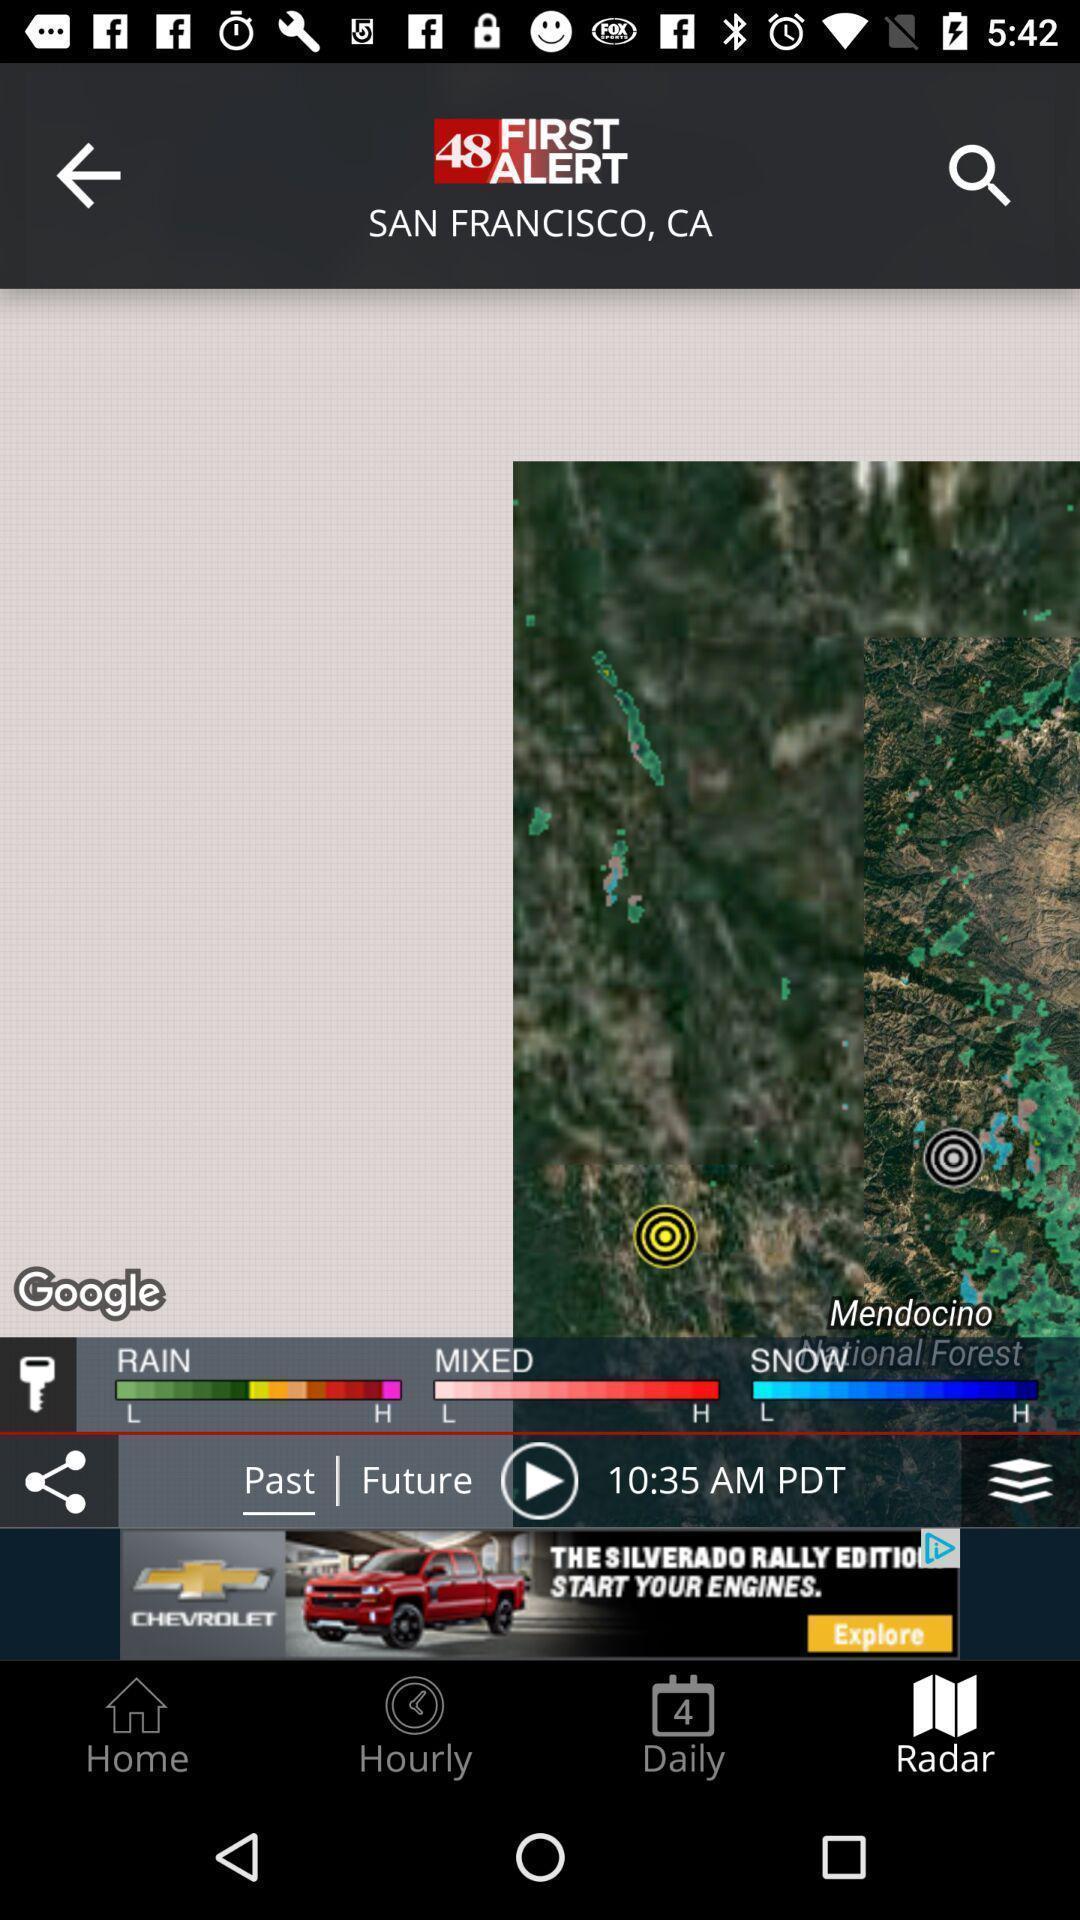Tell me what you see in this picture. Screen displaying the radar page of a location. 